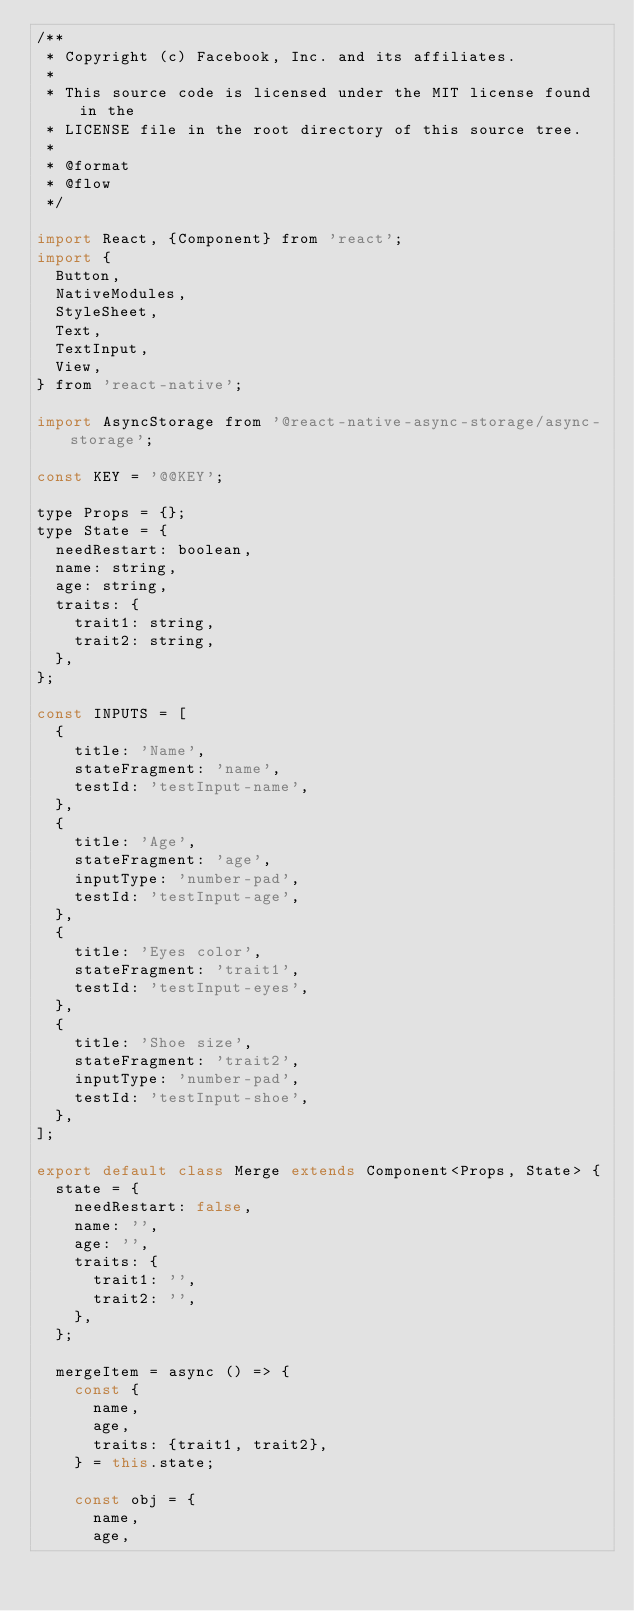<code> <loc_0><loc_0><loc_500><loc_500><_JavaScript_>/**
 * Copyright (c) Facebook, Inc. and its affiliates.
 *
 * This source code is licensed under the MIT license found in the
 * LICENSE file in the root directory of this source tree.
 *
 * @format
 * @flow
 */

import React, {Component} from 'react';
import {
  Button,
  NativeModules,
  StyleSheet,
  Text,
  TextInput,
  View,
} from 'react-native';

import AsyncStorage from '@react-native-async-storage/async-storage';

const KEY = '@@KEY';

type Props = {};
type State = {
  needRestart: boolean,
  name: string,
  age: string,
  traits: {
    trait1: string,
    trait2: string,
  },
};

const INPUTS = [
  {
    title: 'Name',
    stateFragment: 'name',
    testId: 'testInput-name',
  },
  {
    title: 'Age',
    stateFragment: 'age',
    inputType: 'number-pad',
    testId: 'testInput-age',
  },
  {
    title: 'Eyes color',
    stateFragment: 'trait1',
    testId: 'testInput-eyes',
  },
  {
    title: 'Shoe size',
    stateFragment: 'trait2',
    inputType: 'number-pad',
    testId: 'testInput-shoe',
  },
];

export default class Merge extends Component<Props, State> {
  state = {
    needRestart: false,
    name: '',
    age: '',
    traits: {
      trait1: '',
      trait2: '',
    },
  };

  mergeItem = async () => {
    const {
      name,
      age,
      traits: {trait1, trait2},
    } = this.state;

    const obj = {
      name,
      age,</code> 